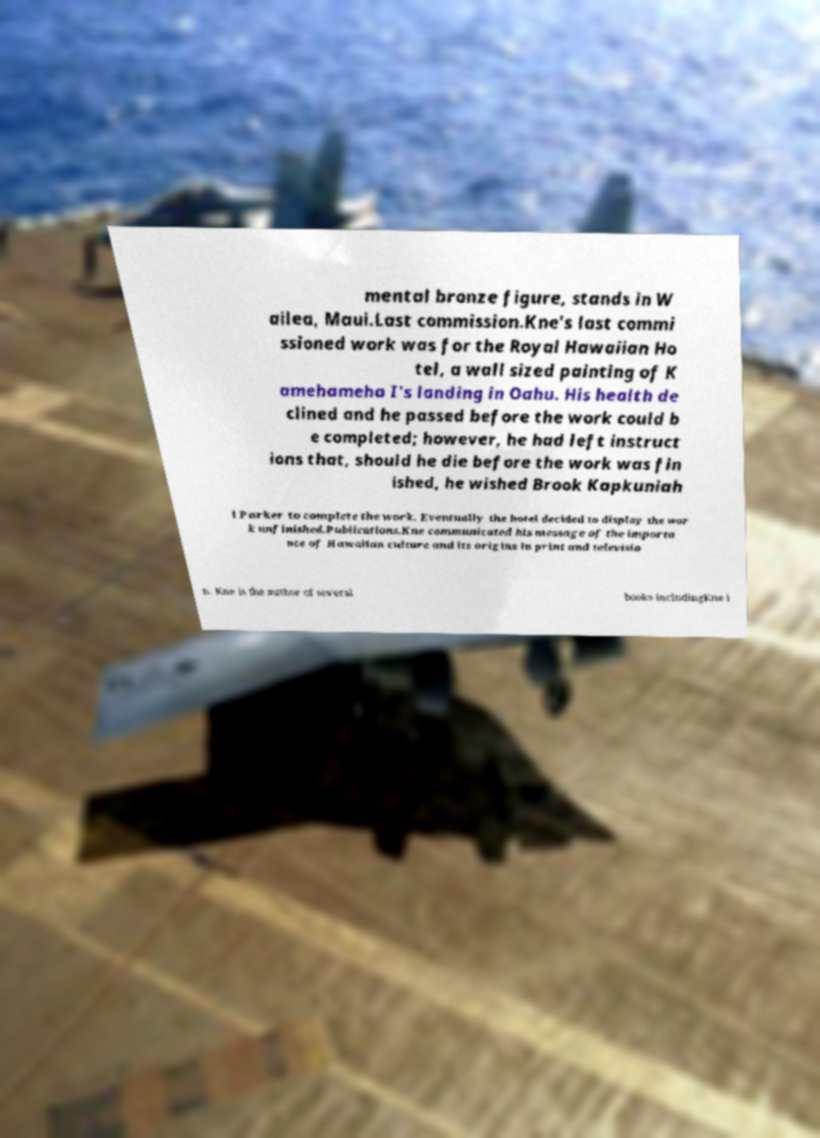For documentation purposes, I need the text within this image transcribed. Could you provide that? mental bronze figure, stands in W ailea, Maui.Last commission.Kne's last commi ssioned work was for the Royal Hawaiian Ho tel, a wall sized painting of K amehameha I's landing in Oahu. His health de clined and he passed before the work could b e completed; however, he had left instruct ions that, should he die before the work was fin ished, he wished Brook Kapkuniah i Parker to complete the work. Eventually the hotel decided to display the wor k unfinished.Publications.Kne communicated his message of the importa nce of Hawaiian culture and its origins in print and televisio n. Kne is the author of several books includingKne i 